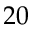<formula> <loc_0><loc_0><loc_500><loc_500>2 0</formula> 